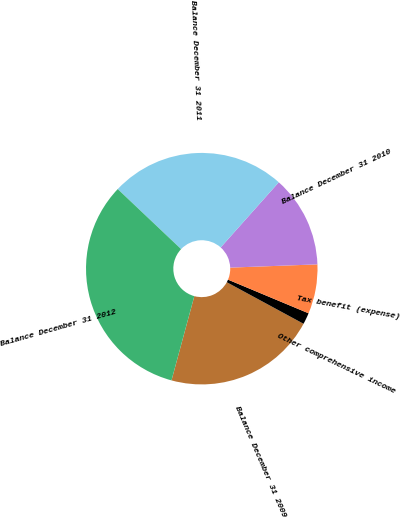<chart> <loc_0><loc_0><loc_500><loc_500><pie_chart><fcel>Balance December 31 2009<fcel>Other comprehensive income<fcel>Tax benefit (expense)<fcel>Balance December 31 2010<fcel>Balance December 31 2011<fcel>Balance December 31 2012<nl><fcel>21.31%<fcel>1.6%<fcel>6.89%<fcel>12.82%<fcel>24.52%<fcel>32.85%<nl></chart> 